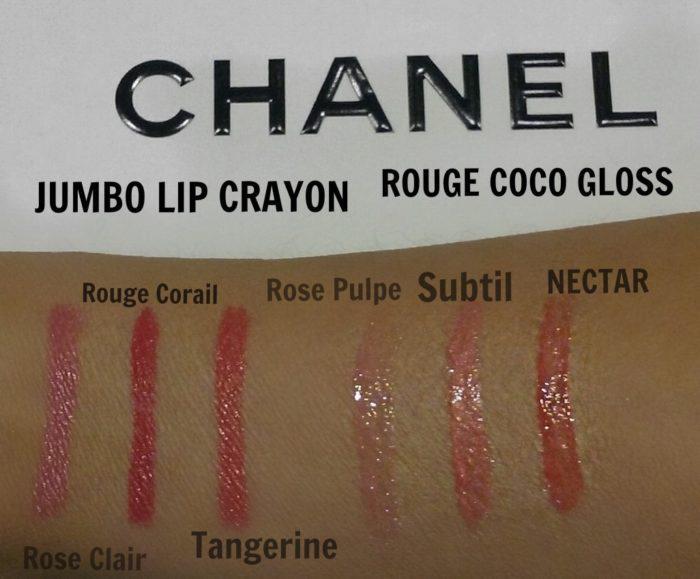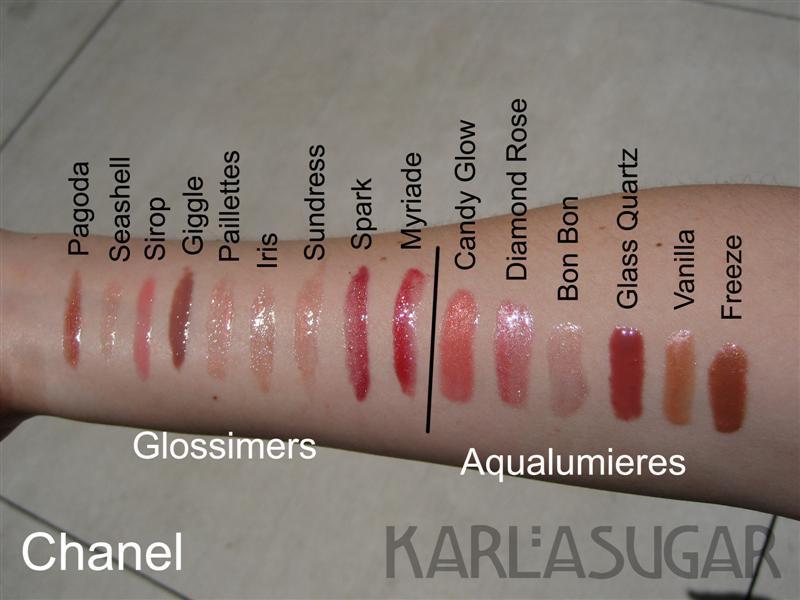The first image is the image on the left, the second image is the image on the right. Assess this claim about the two images: "The person in the left image has lighter skin than the person in the right image.". Correct or not? Answer yes or no. No. The first image is the image on the left, the second image is the image on the right. Assess this claim about the two images: "Each image shows lipstick marks on skin displayed in a horizontal row.". Correct or not? Answer yes or no. Yes. 